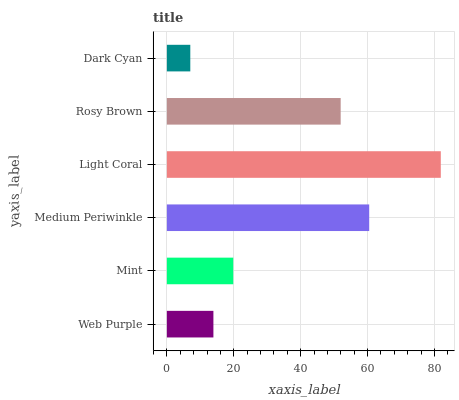Is Dark Cyan the minimum?
Answer yes or no. Yes. Is Light Coral the maximum?
Answer yes or no. Yes. Is Mint the minimum?
Answer yes or no. No. Is Mint the maximum?
Answer yes or no. No. Is Mint greater than Web Purple?
Answer yes or no. Yes. Is Web Purple less than Mint?
Answer yes or no. Yes. Is Web Purple greater than Mint?
Answer yes or no. No. Is Mint less than Web Purple?
Answer yes or no. No. Is Rosy Brown the high median?
Answer yes or no. Yes. Is Mint the low median?
Answer yes or no. Yes. Is Light Coral the high median?
Answer yes or no. No. Is Medium Periwinkle the low median?
Answer yes or no. No. 